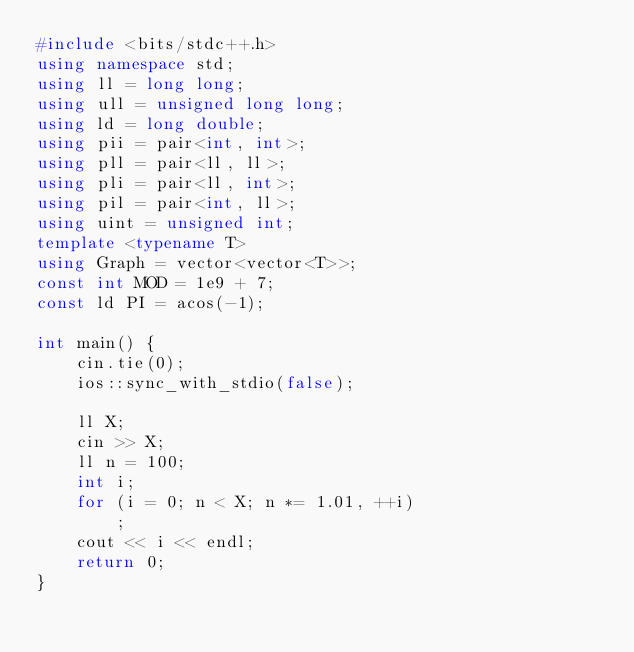Convert code to text. <code><loc_0><loc_0><loc_500><loc_500><_C++_>#include <bits/stdc++.h>
using namespace std;
using ll = long long;
using ull = unsigned long long;
using ld = long double;
using pii = pair<int, int>;
using pll = pair<ll, ll>;
using pli = pair<ll, int>;
using pil = pair<int, ll>;
using uint = unsigned int;
template <typename T>
using Graph = vector<vector<T>>;
const int MOD = 1e9 + 7;
const ld PI = acos(-1);

int main() {
    cin.tie(0);
    ios::sync_with_stdio(false);

    ll X;
    cin >> X;
    ll n = 100;
    int i;
    for (i = 0; n < X; n *= 1.01, ++i)
        ;
    cout << i << endl;
    return 0;
}
</code> 